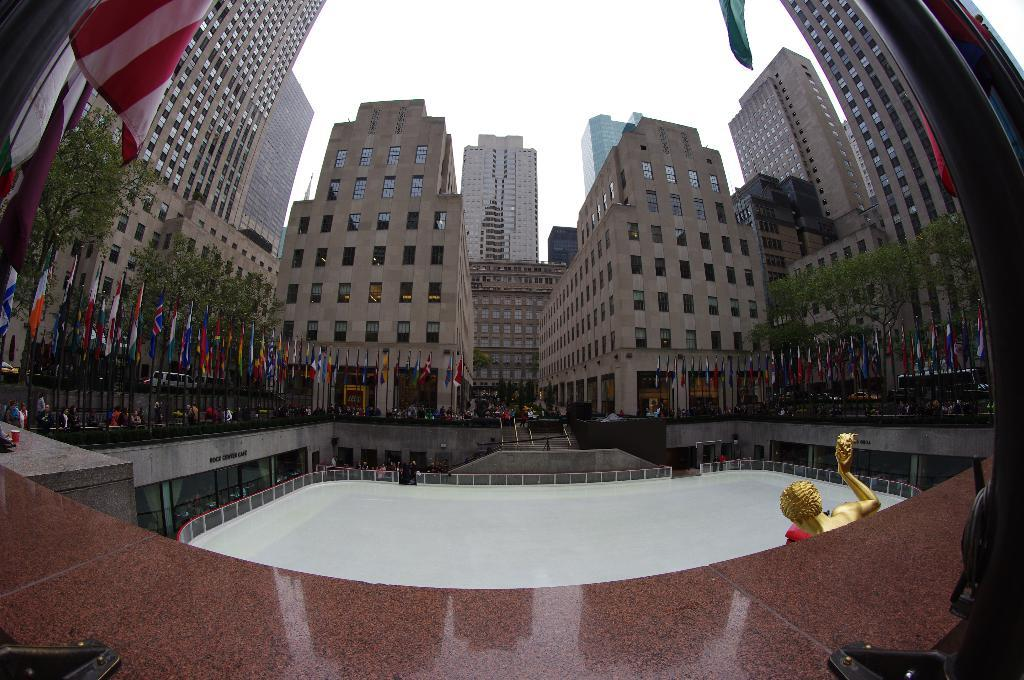What type of structures can be seen in the image? There are buildings in the image. What natural elements are present in the image? There are trees in the image. What decorative or symbolic items can be seen in the image? There are flags in the image. What architectural features are visible in the image? There are poles in the image. Who or what is present in the image? There are people in the image. What is visible at the top of the image? The sky is visible at the top of the image. What type of wilderness can be seen in the image? There is no wilderness present in the image; it features buildings, trees, flags, poles, people, and the sky. What type of frame is used to display the image? The question about the frame is not relevant to the image itself, as it refers to the physical presentation of the image rather than its content. 